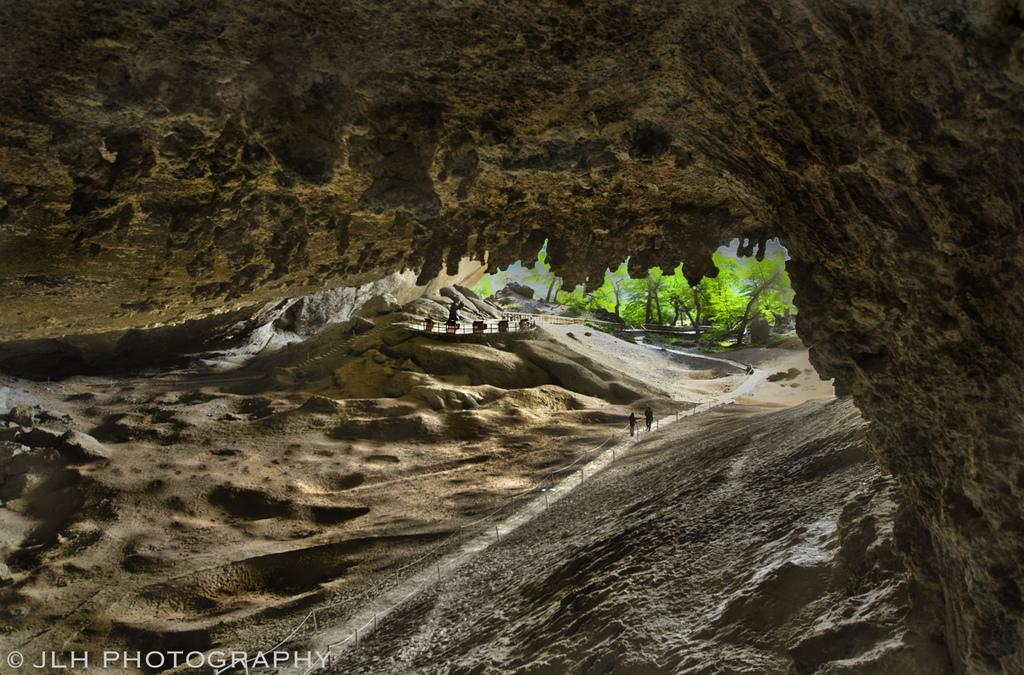What type of natural elements can be seen in the image? There are trees in the image. What type of man-made structure is present in the image? There is fencing in the image. Are there any living beings visible in the image? Yes, there are people in the image. What type of geological feature can be seen in the image? There is a rock in the image. Where is the store located in the image? There is no store present in the image. How many snakes can be seen slithering on the rock in the image? There are no snakes present in the image. 